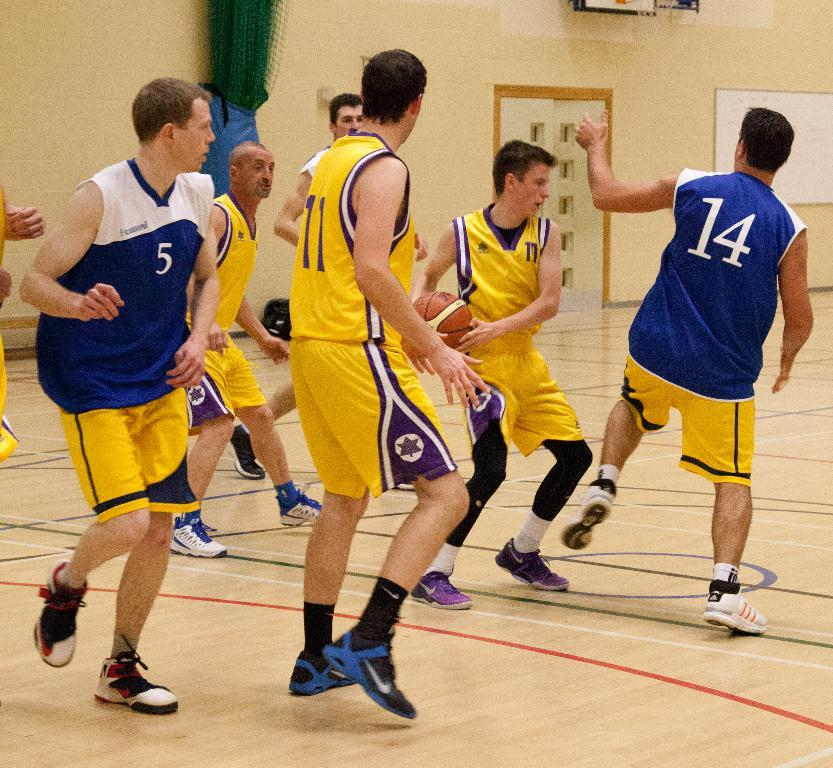<image>
Give a short and clear explanation of the subsequent image. Basketball player number 5 sneaks behind opponent number 11. 